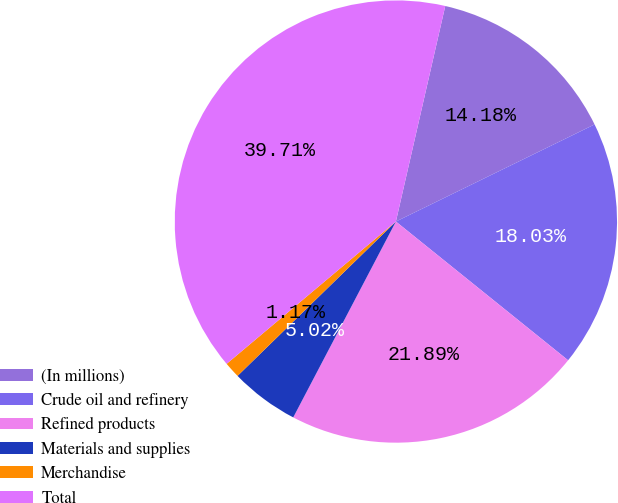<chart> <loc_0><loc_0><loc_500><loc_500><pie_chart><fcel>(In millions)<fcel>Crude oil and refinery<fcel>Refined products<fcel>Materials and supplies<fcel>Merchandise<fcel>Total<nl><fcel>14.18%<fcel>18.03%<fcel>21.89%<fcel>5.02%<fcel>1.17%<fcel>39.71%<nl></chart> 